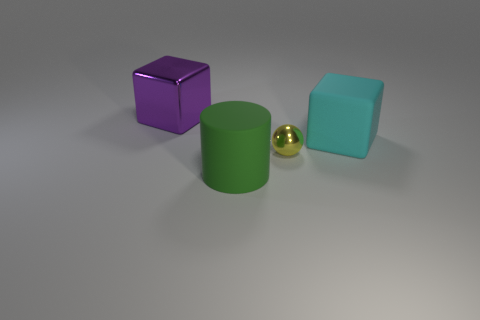There is a big rubber cube; is its color the same as the large object behind the matte cube?
Your response must be concise. No. There is a thing behind the block to the right of the cylinder; what is its material?
Ensure brevity in your answer.  Metal. How many big things are both behind the cylinder and in front of the small ball?
Your answer should be compact. 0. What number of other things are the same size as the yellow ball?
Your answer should be compact. 0. Do the big matte thing left of the tiny yellow shiny sphere and the object to the left of the green cylinder have the same shape?
Give a very brief answer. No. Are there any large metal blocks left of the yellow sphere?
Your response must be concise. Yes. There is a matte thing that is the same shape as the purple shiny thing; what color is it?
Offer a terse response. Cyan. Is there any other thing that has the same shape as the tiny yellow metallic thing?
Ensure brevity in your answer.  No. What is the large cube right of the purple shiny cube made of?
Make the answer very short. Rubber. What is the size of the purple metallic thing that is the same shape as the cyan rubber thing?
Your answer should be very brief. Large. 